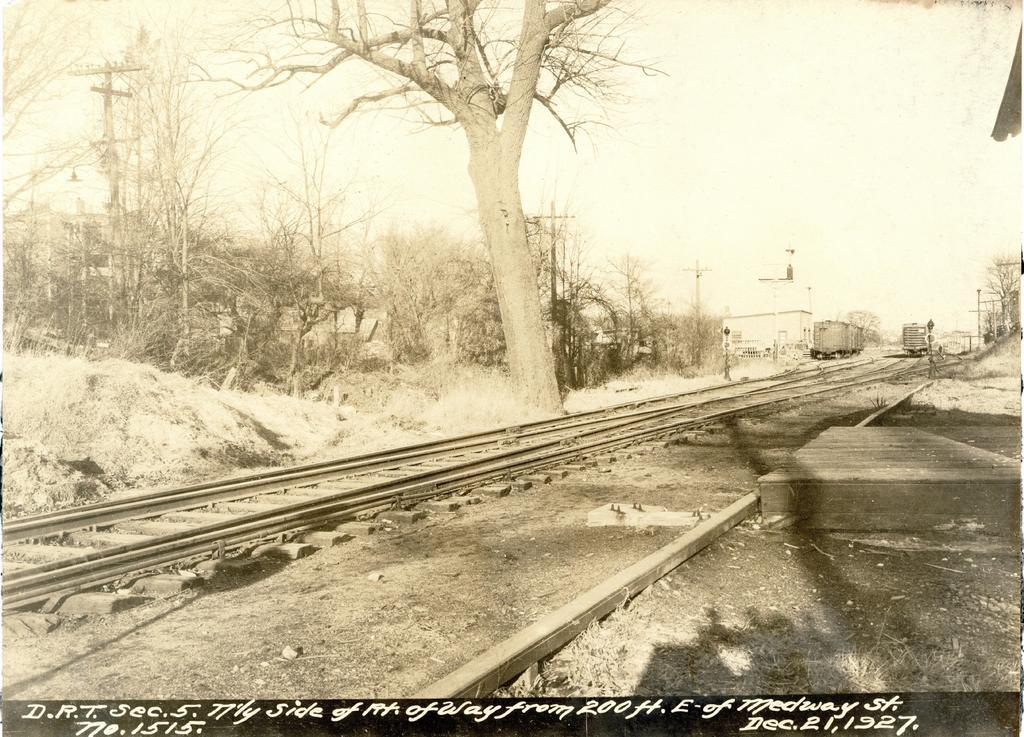What type of transportation infrastructure is visible in the image? There are railway tracks in the image. What vehicles are present on the railway tracks? There are trains in the image. What type of natural elements can be seen in the image? There are trees in the image. What type of man-made structure is visible in the image? There is a building in the image. What type of utility infrastructure is visible in the image? There are poles in the image. Can you tell me where the pot is located in the image? There is no pot present in the image. What part of the brain can be seen in the image? There is no brain visible in the image. 